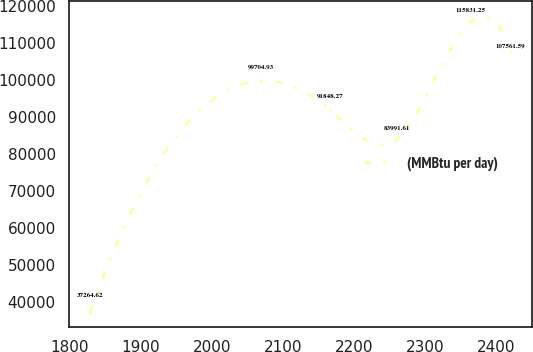Convert chart to OTSL. <chart><loc_0><loc_0><loc_500><loc_500><line_chart><ecel><fcel>(MMBtu per day)<nl><fcel>1828.46<fcel>37264.6<nl><fcel>2068.72<fcel>99704.9<nl><fcel>2166.36<fcel>91848.3<nl><fcel>2260.73<fcel>83991.6<nl><fcel>2364.72<fcel>115831<nl><fcel>2420.72<fcel>107562<nl></chart> 